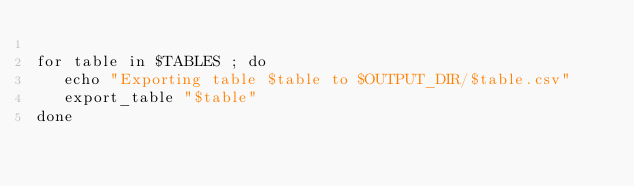Convert code to text. <code><loc_0><loc_0><loc_500><loc_500><_Bash_>
for table in $TABLES ; do
   echo "Exporting table $table to $OUTPUT_DIR/$table.csv"
   export_table "$table"
done
</code> 